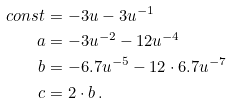<formula> <loc_0><loc_0><loc_500><loc_500>c o n s t & = - 3 u - 3 u ^ { - 1 } \\ a & = - 3 u ^ { - 2 } - 1 2 u ^ { - 4 } \\ b & = - 6 . 7 u ^ { - 5 } - 1 2 \cdot 6 . 7 u ^ { - 7 } \\ c & = 2 \cdot b \, .</formula> 